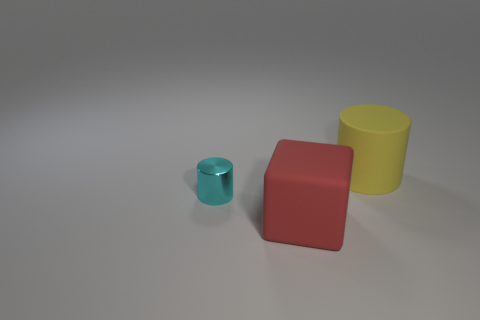What number of objects are either large matte objects that are in front of the large matte cylinder or cylinders behind the cyan shiny object?
Provide a succinct answer. 2. Do the matte thing that is behind the large rubber cube and the rubber object in front of the large yellow object have the same color?
Give a very brief answer. No. The thing that is both right of the cyan cylinder and behind the red object has what shape?
Your response must be concise. Cylinder. The thing that is the same size as the matte cylinder is what color?
Provide a succinct answer. Red. Are there any big spheres of the same color as the small cylinder?
Give a very brief answer. No. Do the matte object that is on the right side of the big red thing and the thing in front of the tiny thing have the same size?
Offer a terse response. Yes. There is a object that is both right of the cyan metallic cylinder and behind the red thing; what material is it?
Your response must be concise. Rubber. How many other things are there of the same size as the yellow cylinder?
Make the answer very short. 1. What is the cylinder that is to the right of the big block made of?
Your answer should be compact. Rubber. Do the small thing and the big yellow object have the same shape?
Your answer should be compact. Yes. 